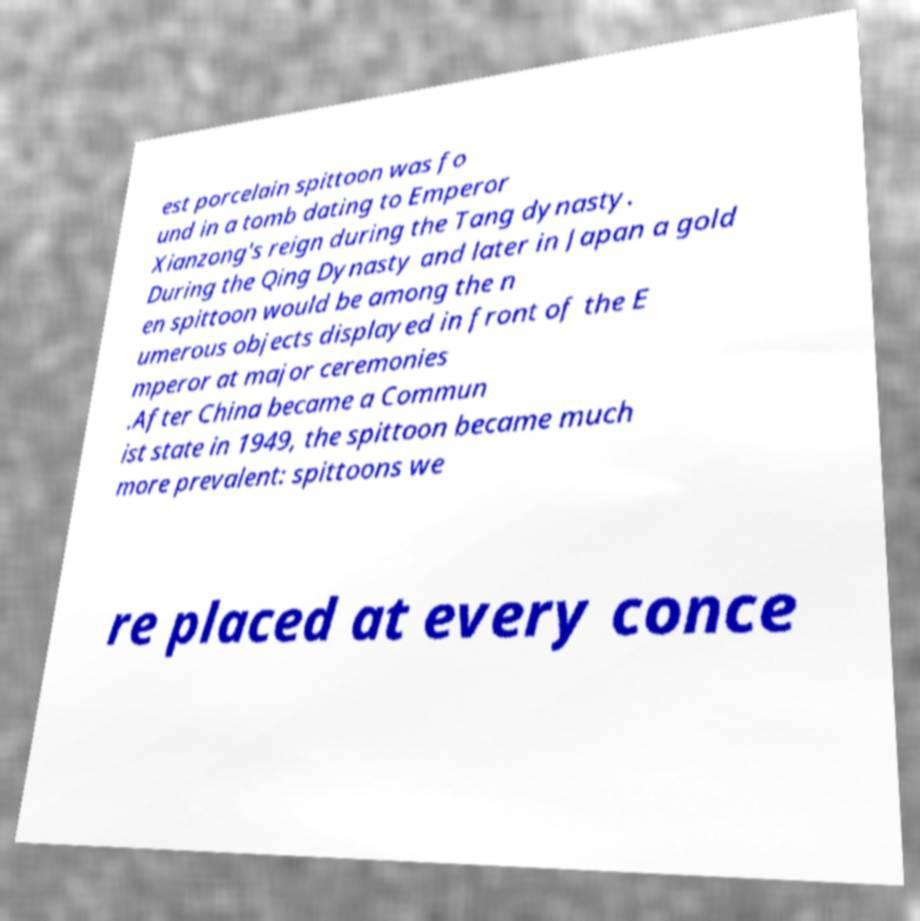I need the written content from this picture converted into text. Can you do that? est porcelain spittoon was fo und in a tomb dating to Emperor Xianzong's reign during the Tang dynasty. During the Qing Dynasty and later in Japan a gold en spittoon would be among the n umerous objects displayed in front of the E mperor at major ceremonies .After China became a Commun ist state in 1949, the spittoon became much more prevalent: spittoons we re placed at every conce 